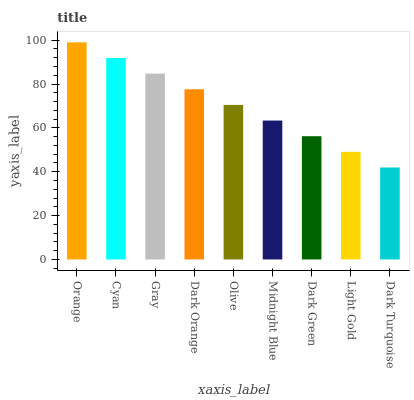Is Dark Turquoise the minimum?
Answer yes or no. Yes. Is Orange the maximum?
Answer yes or no. Yes. Is Cyan the minimum?
Answer yes or no. No. Is Cyan the maximum?
Answer yes or no. No. Is Orange greater than Cyan?
Answer yes or no. Yes. Is Cyan less than Orange?
Answer yes or no. Yes. Is Cyan greater than Orange?
Answer yes or no. No. Is Orange less than Cyan?
Answer yes or no. No. Is Olive the high median?
Answer yes or no. Yes. Is Olive the low median?
Answer yes or no. Yes. Is Midnight Blue the high median?
Answer yes or no. No. Is Dark Orange the low median?
Answer yes or no. No. 